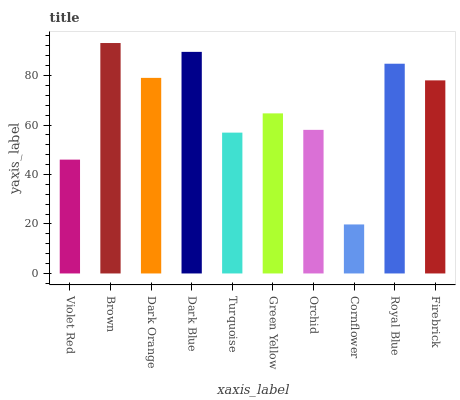Is Cornflower the minimum?
Answer yes or no. Yes. Is Brown the maximum?
Answer yes or no. Yes. Is Dark Orange the minimum?
Answer yes or no. No. Is Dark Orange the maximum?
Answer yes or no. No. Is Brown greater than Dark Orange?
Answer yes or no. Yes. Is Dark Orange less than Brown?
Answer yes or no. Yes. Is Dark Orange greater than Brown?
Answer yes or no. No. Is Brown less than Dark Orange?
Answer yes or no. No. Is Firebrick the high median?
Answer yes or no. Yes. Is Green Yellow the low median?
Answer yes or no. Yes. Is Orchid the high median?
Answer yes or no. No. Is Brown the low median?
Answer yes or no. No. 